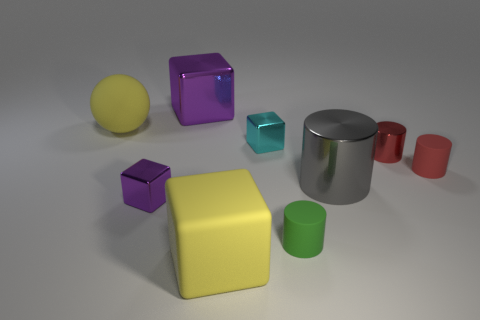Subtract all large metallic cubes. How many cubes are left? 3 Add 1 purple metallic spheres. How many objects exist? 10 Subtract all blue cylinders. How many purple blocks are left? 2 Subtract all cyan blocks. How many blocks are left? 3 Subtract all blocks. How many objects are left? 5 Add 7 cyan metallic cubes. How many cyan metallic cubes are left? 8 Add 4 big brown cubes. How many big brown cubes exist? 4 Subtract 0 green spheres. How many objects are left? 9 Subtract all brown cylinders. Subtract all cyan balls. How many cylinders are left? 4 Subtract all tiny purple shiny blocks. Subtract all large yellow rubber spheres. How many objects are left? 7 